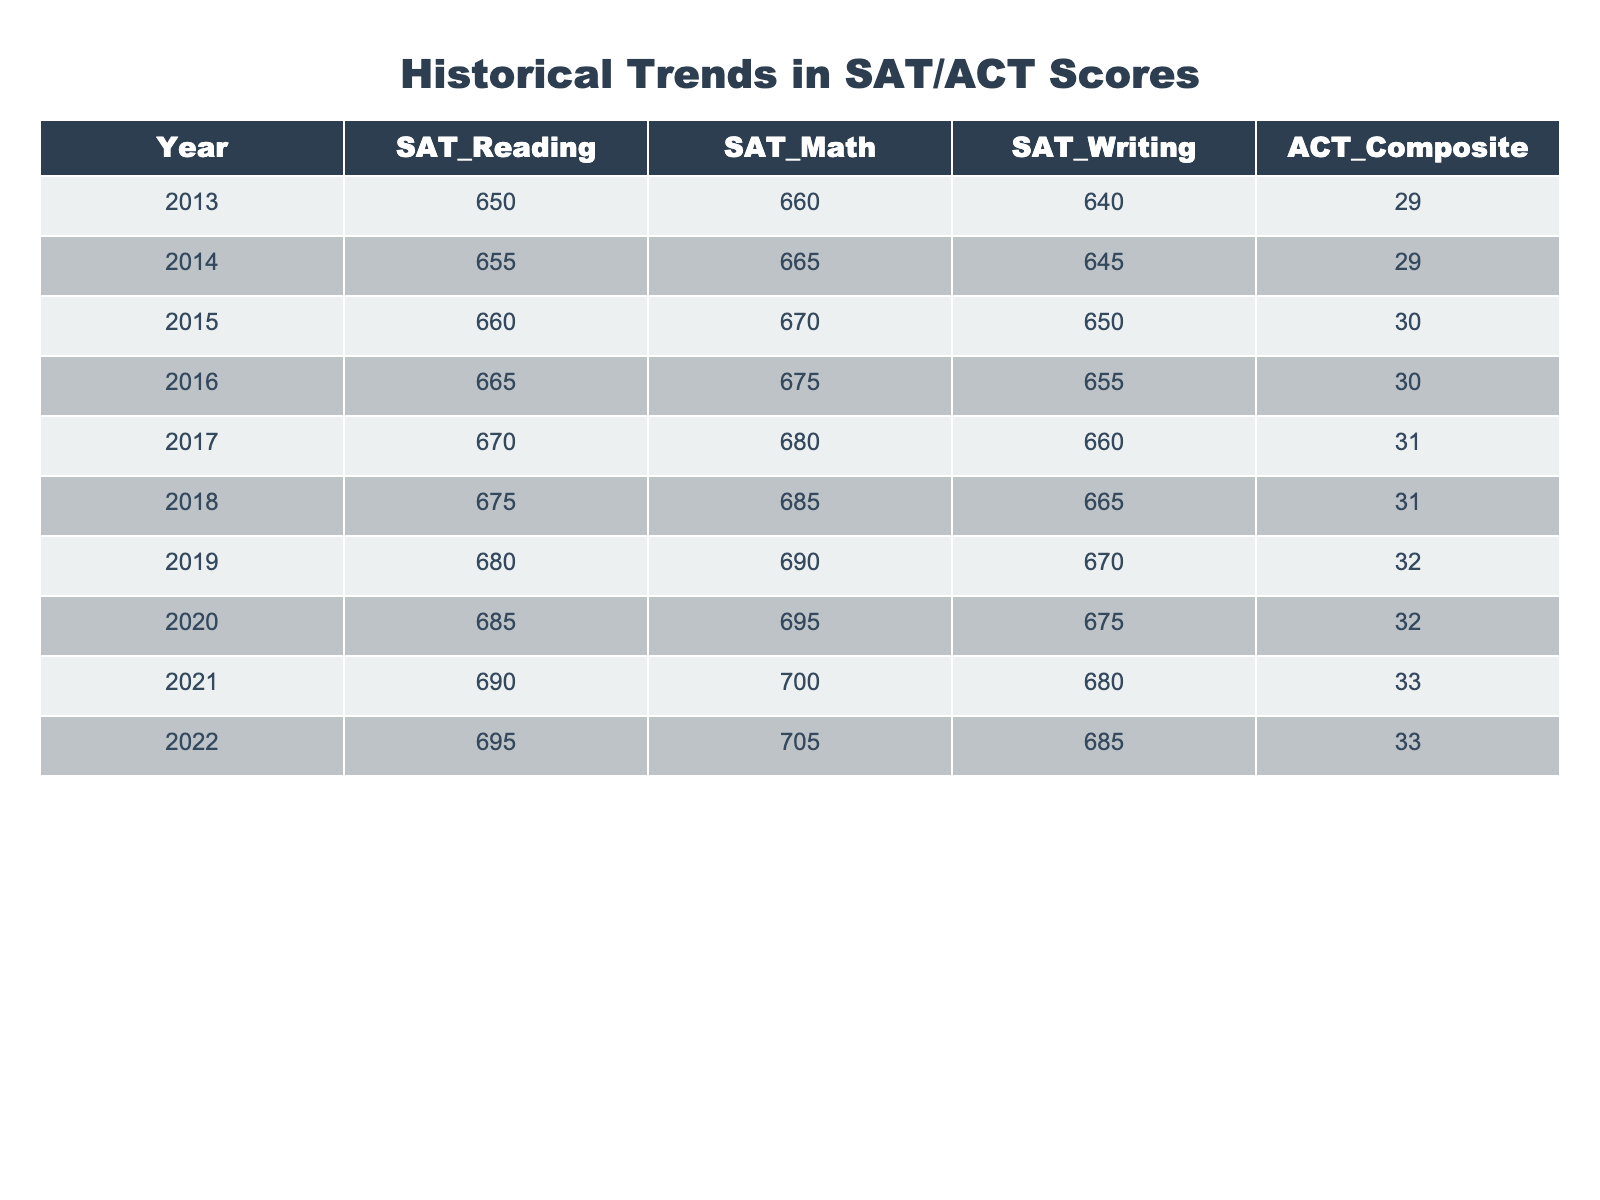What is the SAT Reading score for the year 2021? The SAT Reading score for 2021 is listed directly in the table under that year, which shows a score of 690.
Answer: 690 What was the highest ACT Composite score recorded in the table? By examining the ACT Composite scores row, the highest score is 33, seen in both 2021 and 2022.
Answer: 33 How much did the SAT Math score increase from 2013 to 2022? The SAT Math score in 2013 was 660, and in 2022 it was 705. To find the increase, subtract 660 from 705: 705 - 660 = 45.
Answer: 45 What is the average SAT Writing score over the ten years? The SAT Writing scores from 2013 to 2022 are 640, 645, 650, 655, 660, 665, 670, 675, 680, and 685. Adding these gives a total of 6,655, which divided by 10 (the number of years) results in 665.5. Rounded, that's 666.
Answer: 666 Did the SAT Reading scores ever decrease from one year to the next? Looking through the SAT Reading scores from 2013 to 2022, each year shows an increase from the previous one. Therefore, the answer is no, they did not decrease.
Answer: No What was the difference between the SAT Writing score in 2018 and the ACT Composite score in the same year? In 2018, the SAT Writing score was 665 and the ACT Composite score was 31. The difference is calculated by subtracting the ACT score from the SAT Writing score: 665 - 31 = 634.
Answer: 634 In which year was the largest increase in SAT Reading scores observed? By reviewing the SAT Reading scores for each year, the score rose from 690 to 695 from 2021 to 2022, which is a 5-point increase, while the largest increase prior was from 2016 to 2017 (665 to 670), a 5-point increase as well. However, both increases are the same, so the largest is either of those two years.
Answer: 2021-2022 or 2016-2017 What overall trend can be observed from the SAT and ACT scores over the decade? By observing the scores from 2013 to 2022, both SAT and ACT scores show a clear upward trend, indicating that students’ scores have been generally increasing over the years.
Answer: Upward trend 